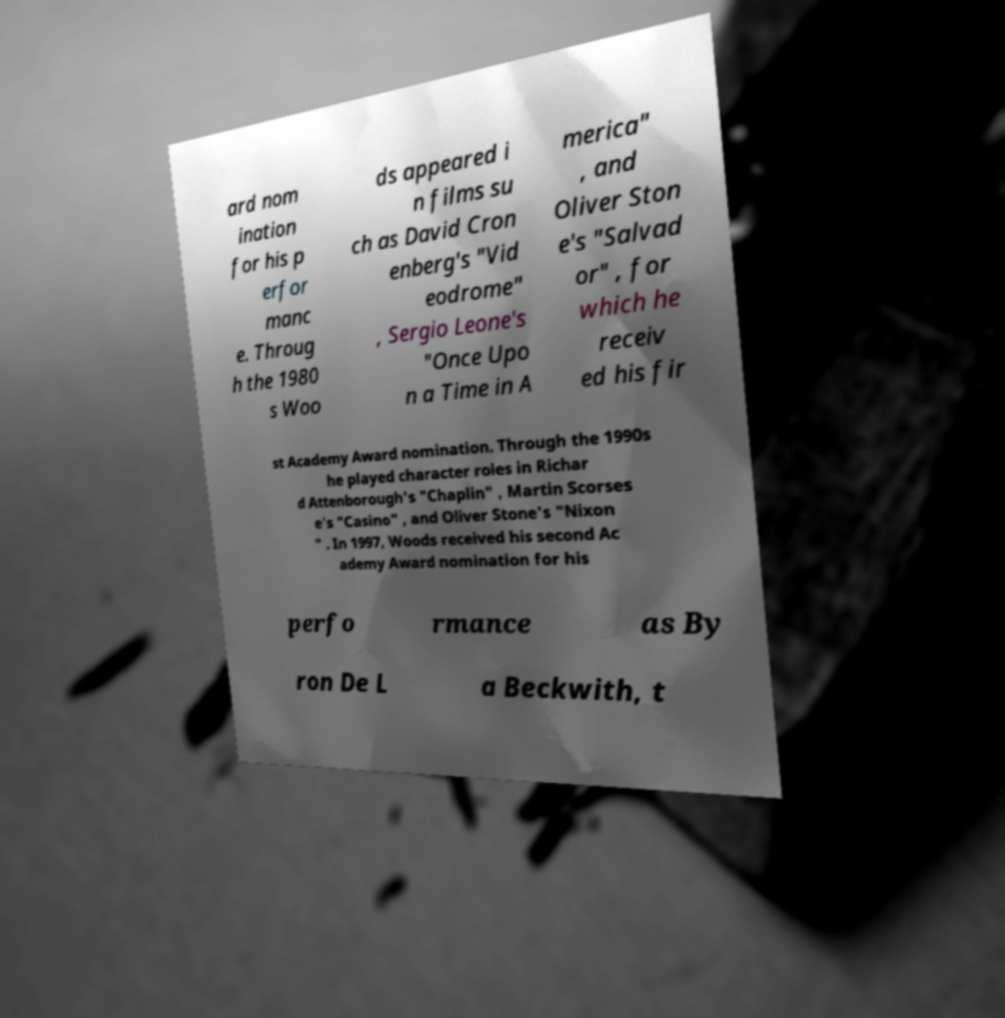Can you accurately transcribe the text from the provided image for me? ard nom ination for his p erfor manc e. Throug h the 1980 s Woo ds appeared i n films su ch as David Cron enberg's "Vid eodrome" , Sergio Leone's "Once Upo n a Time in A merica" , and Oliver Ston e's "Salvad or" , for which he receiv ed his fir st Academy Award nomination. Through the 1990s he played character roles in Richar d Attenborough's "Chaplin" , Martin Scorses e's "Casino" , and Oliver Stone's "Nixon " . In 1997, Woods received his second Ac ademy Award nomination for his perfo rmance as By ron De L a Beckwith, t 